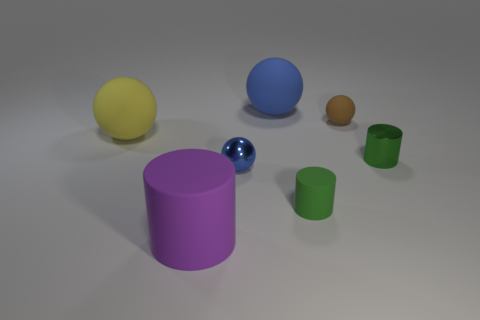Are any green matte cylinders visible?
Your answer should be compact. Yes. What material is the other green thing that is the same shape as the green shiny thing?
Your answer should be compact. Rubber. Are there any small brown spheres on the left side of the big blue matte thing?
Make the answer very short. No. Does the blue ball to the left of the large blue rubber ball have the same material as the large yellow thing?
Make the answer very short. No. Are there any big things that have the same color as the tiny metal sphere?
Provide a succinct answer. Yes. What is the shape of the small blue object?
Ensure brevity in your answer.  Sphere. What is the color of the matte sphere that is on the left side of the cylinder on the left side of the small blue metallic sphere?
Provide a short and direct response. Yellow. What size is the rubber sphere in front of the brown thing?
Your answer should be compact. Large. Is there a green object that has the same material as the purple cylinder?
Make the answer very short. Yes. How many small blue metal objects have the same shape as the blue rubber thing?
Keep it short and to the point. 1. 